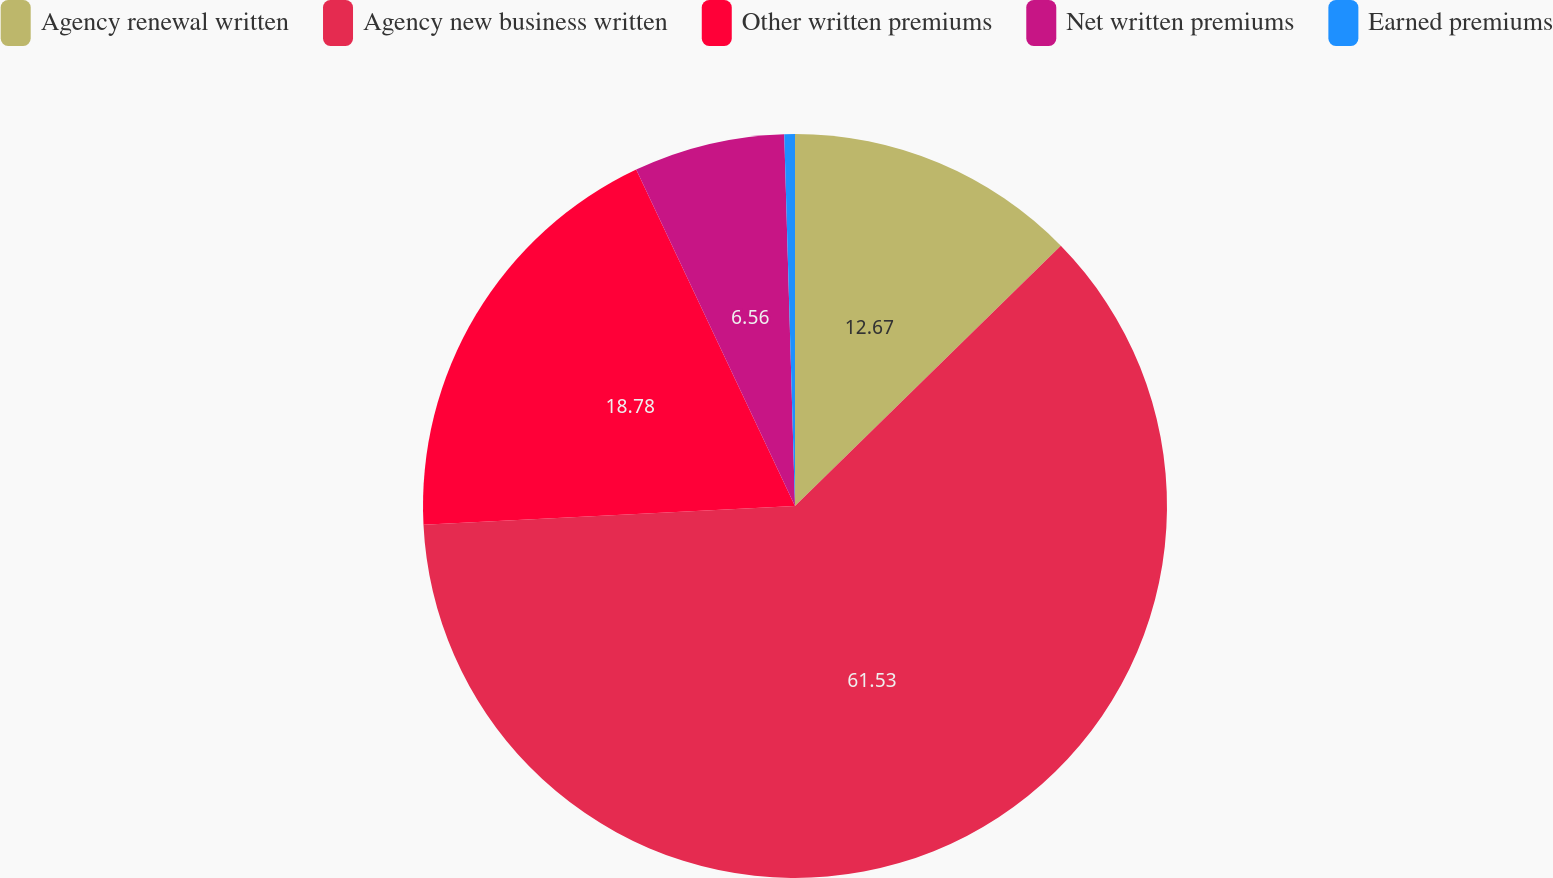Convert chart. <chart><loc_0><loc_0><loc_500><loc_500><pie_chart><fcel>Agency renewal written<fcel>Agency new business written<fcel>Other written premiums<fcel>Net written premiums<fcel>Earned premiums<nl><fcel>12.67%<fcel>61.53%<fcel>18.78%<fcel>6.56%<fcel>0.46%<nl></chart> 